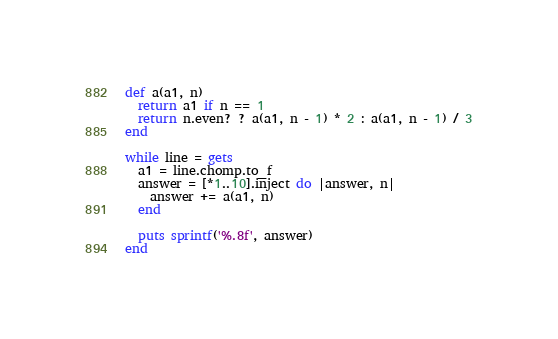<code> <loc_0><loc_0><loc_500><loc_500><_Ruby_>def a(a1, n)
  return a1 if n == 1
  return n.even? ? a(a1, n - 1) * 2 : a(a1, n - 1) / 3
end

while line = gets
  a1 = line.chomp.to_f
  answer = [*1..10].inject do |answer, n|
    answer += a(a1, n)
  end

  puts sprintf('%.8f', answer)
end</code> 